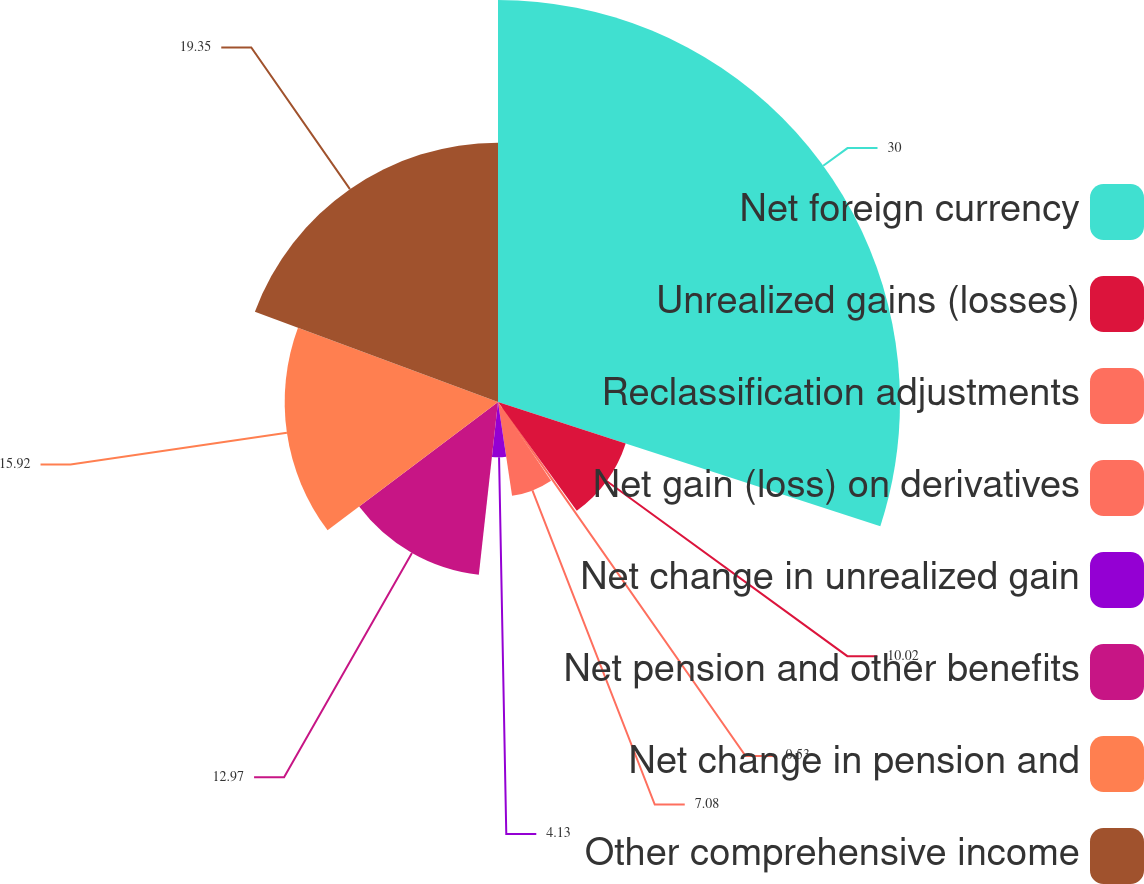Convert chart. <chart><loc_0><loc_0><loc_500><loc_500><pie_chart><fcel>Net foreign currency<fcel>Unrealized gains (losses)<fcel>Reclassification adjustments<fcel>Net gain (loss) on derivatives<fcel>Net change in unrealized gain<fcel>Net pension and other benefits<fcel>Net change in pension and<fcel>Other comprehensive income<nl><fcel>30.0%<fcel>10.02%<fcel>0.53%<fcel>7.08%<fcel>4.13%<fcel>12.97%<fcel>15.92%<fcel>19.35%<nl></chart> 